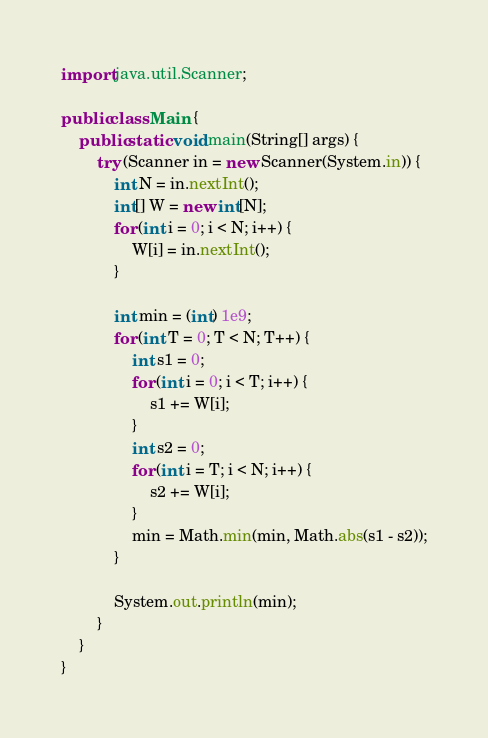Convert code to text. <code><loc_0><loc_0><loc_500><loc_500><_Java_>import java.util.Scanner;

public class Main {
    public static void main(String[] args) {
        try (Scanner in = new Scanner(System.in)) {
            int N = in.nextInt();
            int[] W = new int[N];
            for (int i = 0; i < N; i++) {
                W[i] = in.nextInt();
            }

            int min = (int) 1e9;
            for (int T = 0; T < N; T++) {
                int s1 = 0;
                for (int i = 0; i < T; i++) {
                    s1 += W[i];
                }
                int s2 = 0;
                for (int i = T; i < N; i++) {
                    s2 += W[i];
                }
                min = Math.min(min, Math.abs(s1 - s2));
            }

            System.out.println(min);
        }
    }
}
</code> 